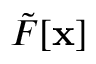Convert formula to latex. <formula><loc_0><loc_0><loc_500><loc_500>\tilde { F } [ x ]</formula> 